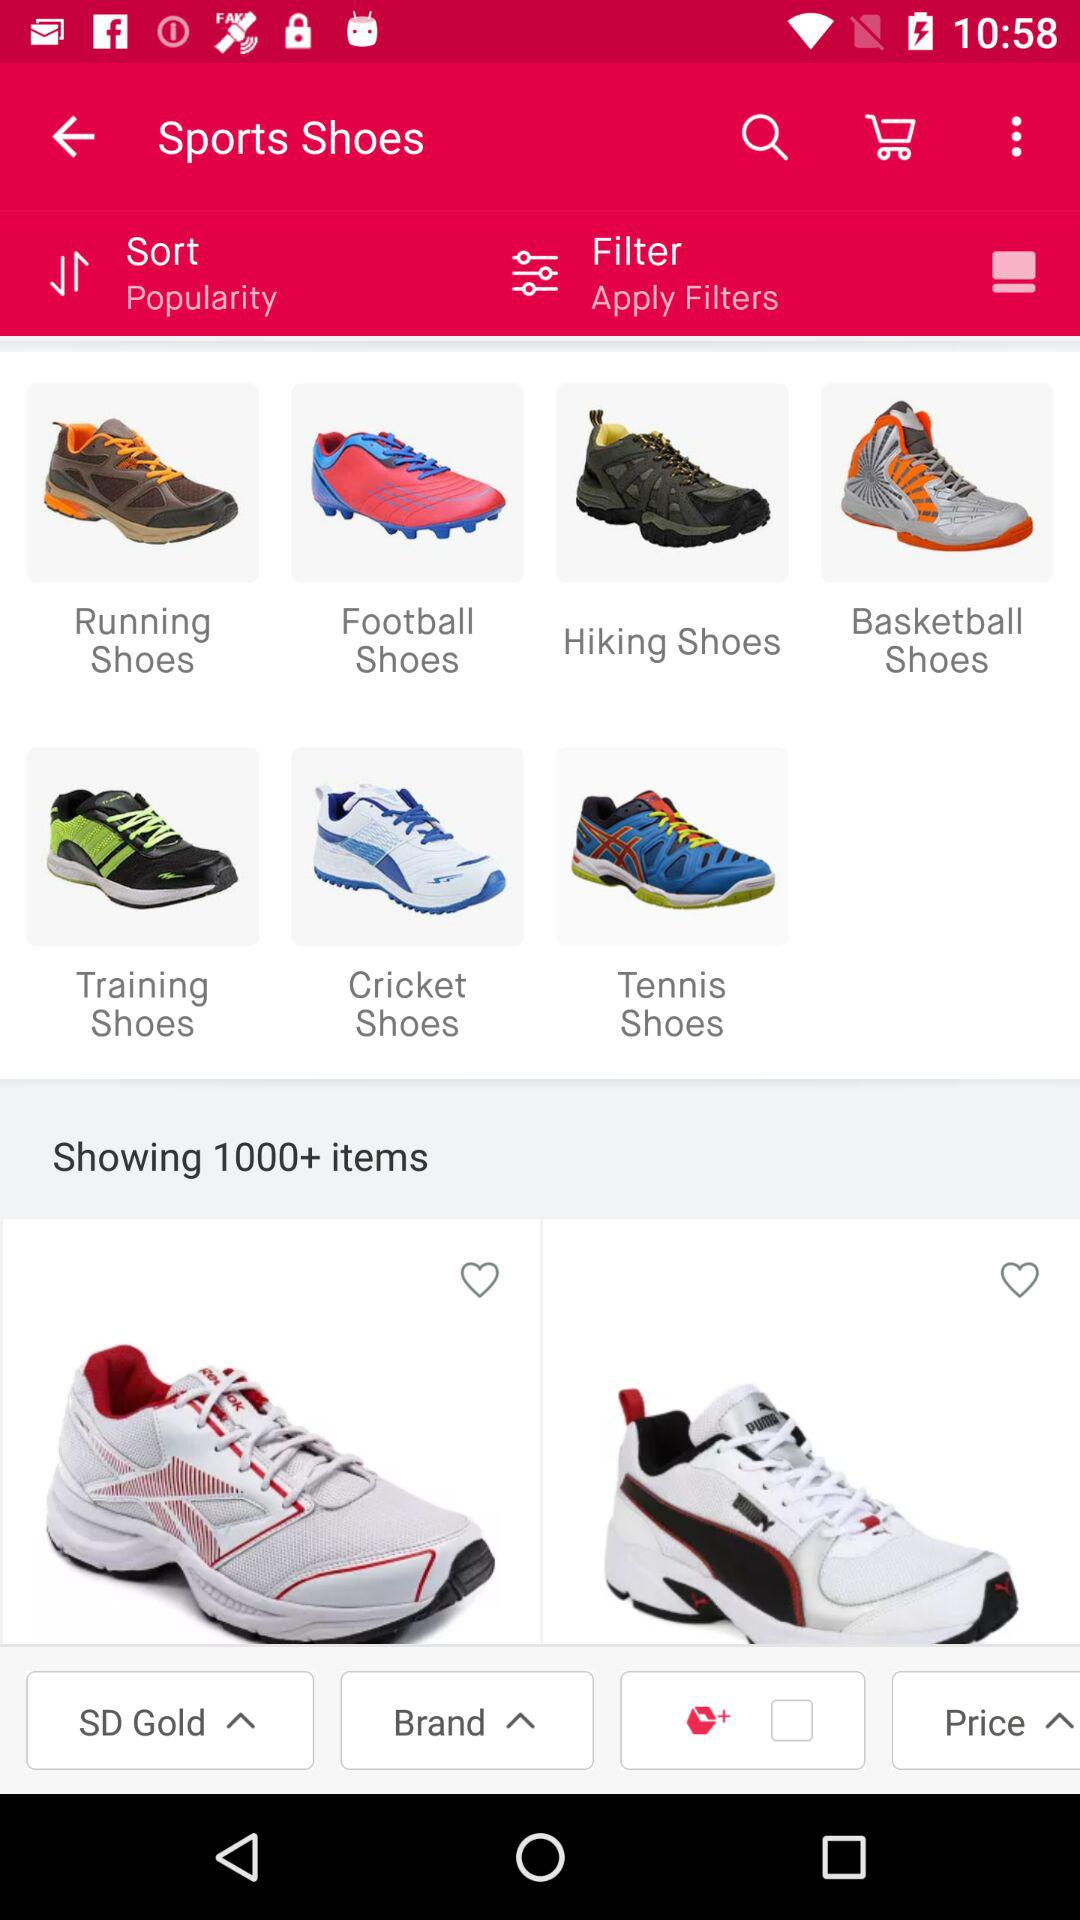How many items are there in total?
Answer the question using a single word or phrase. 1000+ 